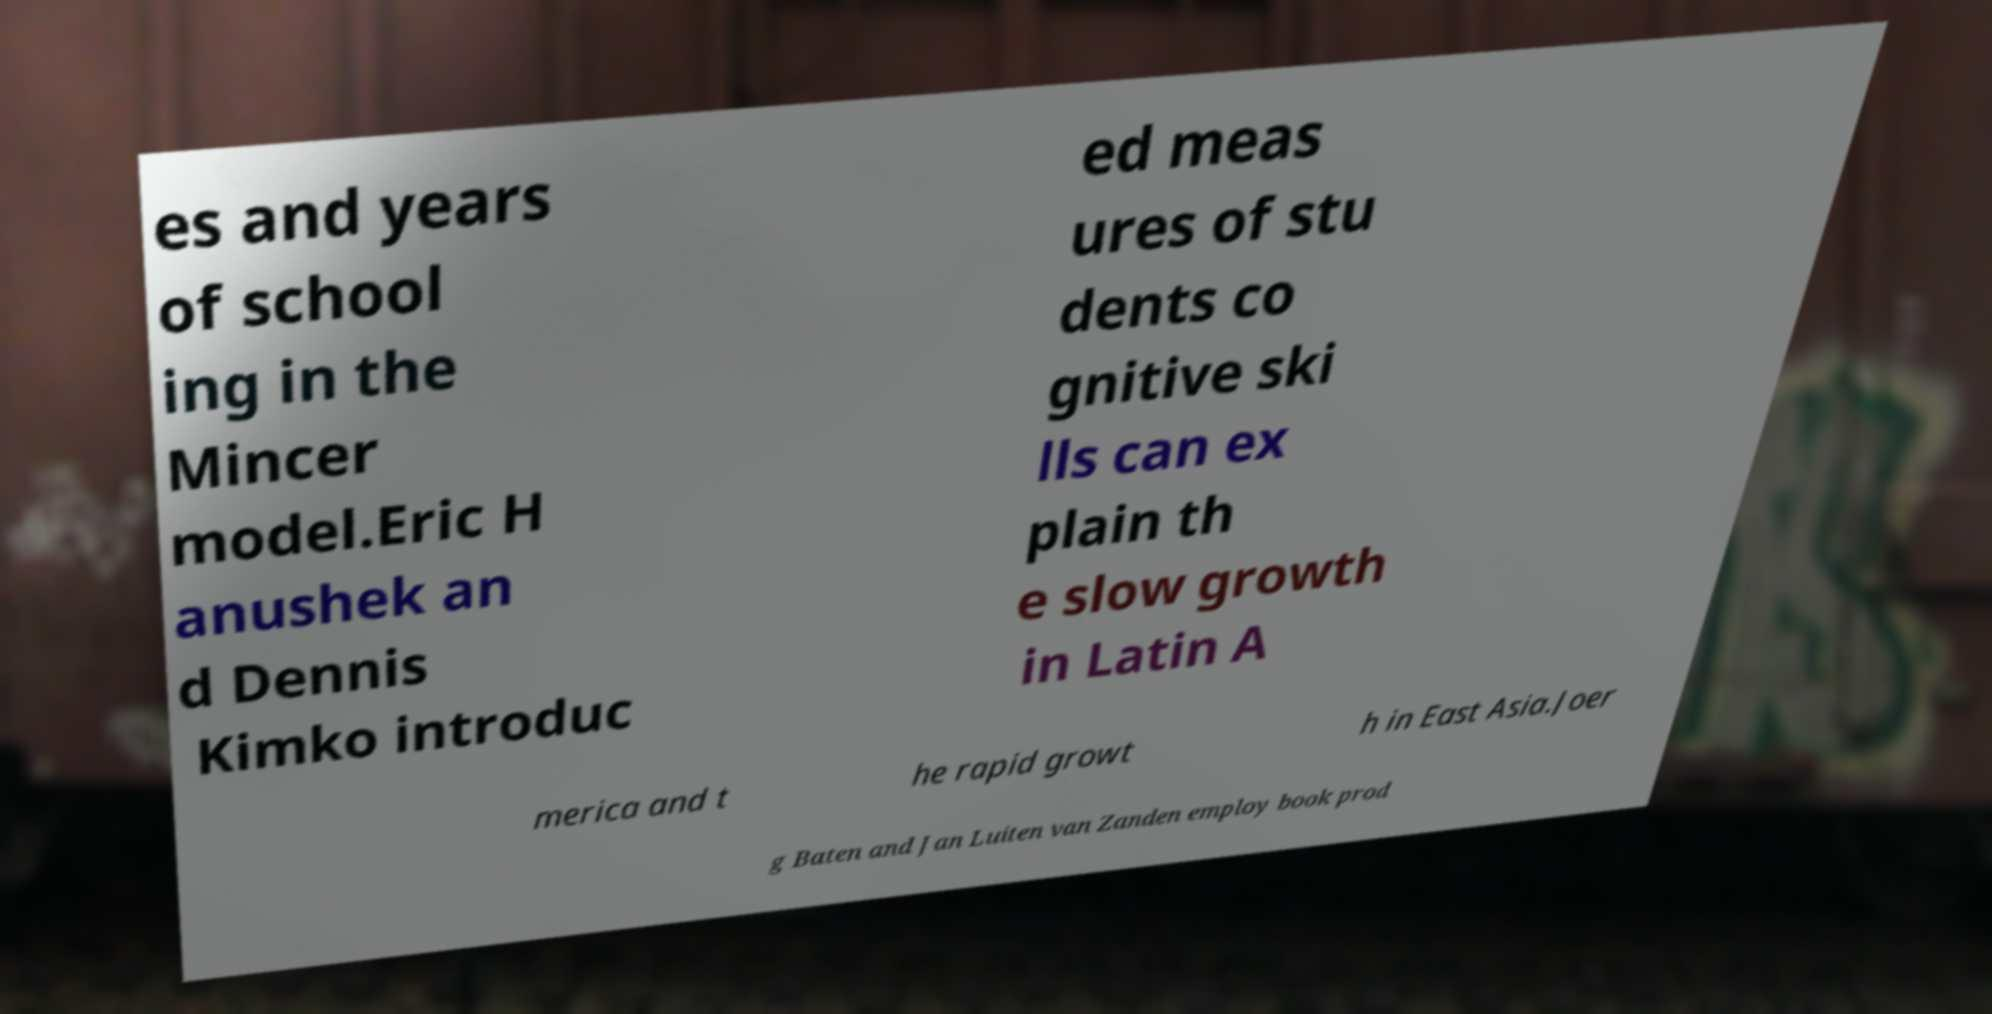Could you extract and type out the text from this image? es and years of school ing in the Mincer model.Eric H anushek an d Dennis Kimko introduc ed meas ures of stu dents co gnitive ski lls can ex plain th e slow growth in Latin A merica and t he rapid growt h in East Asia.Joer g Baten and Jan Luiten van Zanden employ book prod 